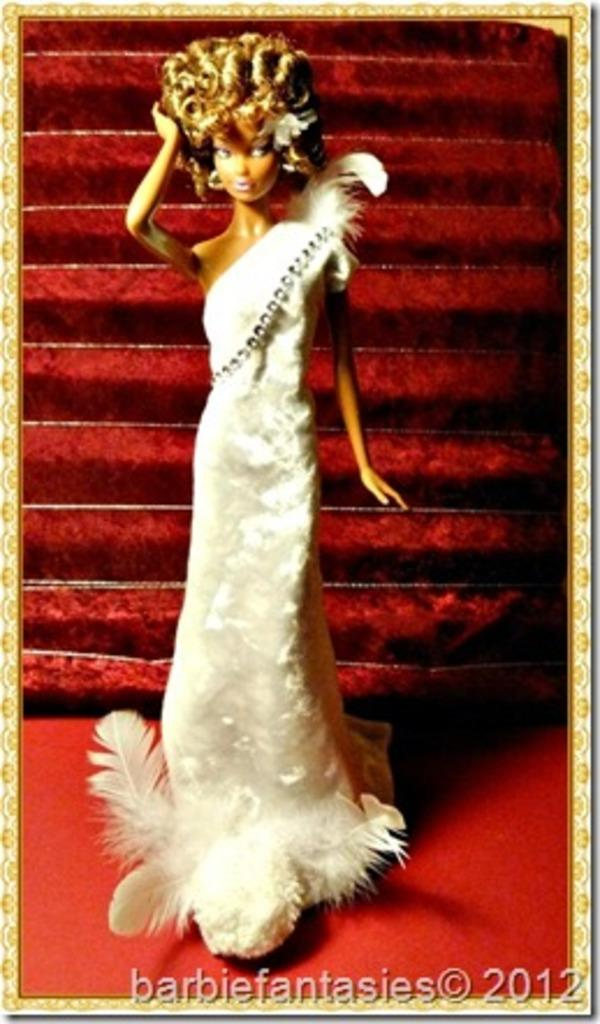What is located in the middle of the image? There is a figure in the middle of the image. What can be found at the bottom of the image? There is some text at the bottom of the image. What type of company is depicted on the figure's shirt in the image? There is no company or shirt visible in the image; it only features a figure and some text at the bottom. What color is the mint that is covering the figure in the image? There is no mint or any indication of a cover in the image; it only features a figure and some text at the bottom. 